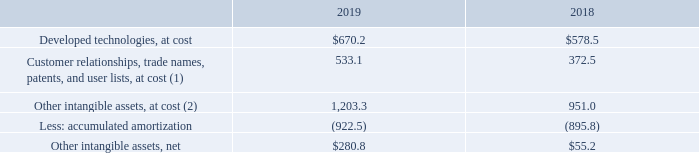Other Intangible Assets, Net
Other intangible assets include developed technologies, customer relationships, trade names, patents, user lists and the related accumulated amortization. These assets are shown as “Developed technologies, net” and as part of “Other assets” in the Consolidated Balance Sheet. The majority of Autodesk’s other intangible assets are amortized to expense over the estimated economic life of the product, which ranges from two to ten years. Amortization expense for developed technologies, customer relationships, trade names, patents, and user lists was $33.5 million in fiscal 2019, $36.6 million in fiscal 2018 and $72.2 million in fiscal 2017.
Other intangible assets and related accumulated amortization at January 31 were as follows:
(1) Included in “Other assets” in the accompanying Consolidated Balance Sheets. (2) Includes the effects of foreign currency translation.
What is the estimated economic life of the product? Ranges from two to ten years. What was the 2017 expense for developed technologies, customer relationships, trade names, patents, and user lists? $72.2 million. What do the other tangible assets consist of? Developed technologies, at cost. What was the difference in customer relationships, trade names, patents, and user lists, at cost from 2018 to 2019?
Answer scale should be: million. 533.1-372.5 
Answer: 160.6. What is the increase in net other tangible assets from 2018 to 2019?
Answer scale should be: million. 280.8-55.2
Answer: 225.6. How much did developed technologies, at cost gain in 2019 over 2018?
Answer scale should be: percent. (670.2 -578.5)/578.5 
Answer: 15.85. 